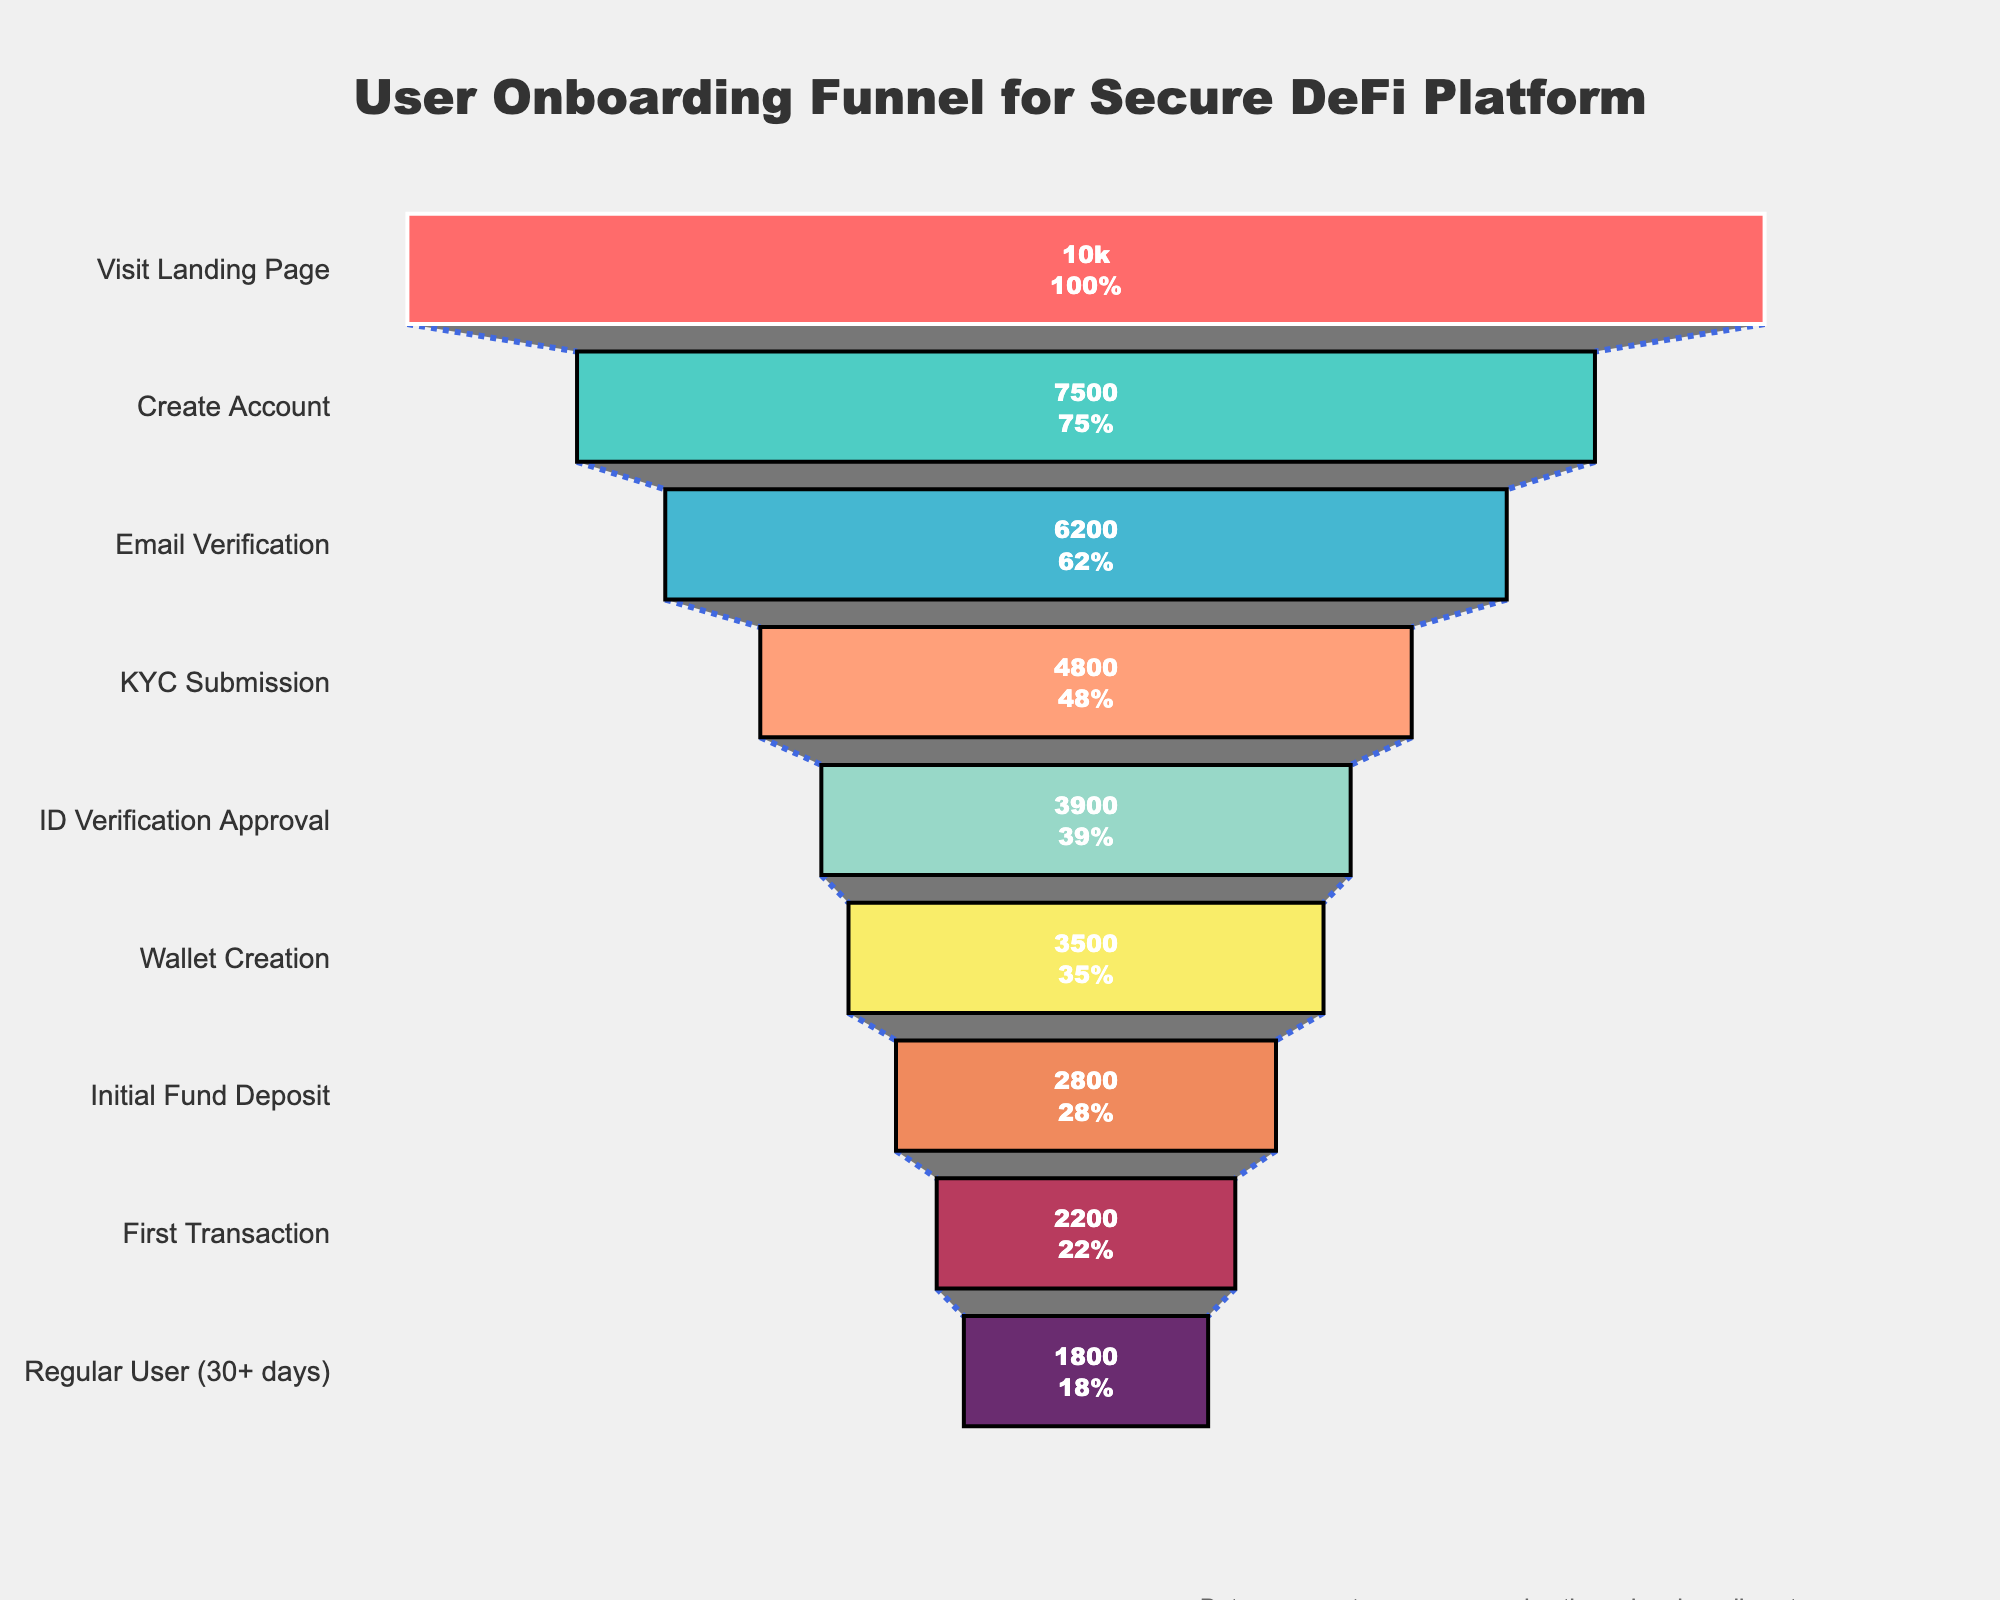What's the title of the funnel chart? The title of the funnel chart is displayed prominently at the top of the figure, which states the purpose or focus of the visualization.
Answer: User Onboarding Funnel for Secure DeFi Platform How many users completed the first transaction? The figure presents the number of users who reach each step of the onboarding process. Locate the step labeled "First Transaction" and refer to its associated user count.
Answer: 2200 What percentage of users completed the KYC Submission compared to the total visits to the landing page? The percentage for each step is calculated by dividing the number of users at that step by the number of users at the first step (Visit Landing Page) and then multiplying by 100. For KYC Submission: (4800/10000) * 100.
Answer: 48% What is the decrease in user count from Create Account to Email Verification? Subtract the number of users in the Email Verification step from the number of users in the Create Account step: 7500 - 6200.
Answer: 1300 Compare the number of users who completed ID Verification Approval and Wallet Creation. Which step had more users? Locate the steps "ID Verification Approval" and "Wallet Creation." Compare their user counts: 3900 (ID Verification Approval) vs 3500 (Wallet Creation).
Answer: ID Verification Approval What is the difference in completion rate between Initial Fund Deposit and Regular User (30+ days)? Compute the completion rate as the percentage of users for each respective step: Initial Fund Deposit (2800/10000) * 100 and Regular User (30+ days) (1800/10000) * 100, then find the difference (28% - 18%).
Answer: 10% How many steps are there in the user onboarding process? Count the number of distinct steps listed along the y-axis of the funnel chart, representing different stages of the user journey.
Answer: 9 At which step is there the highest drop-off rate? To determine the highest drop-off rate, identify where the difference between the user counts for consecutive steps is the largest. Analyze the differences between each step to find the maximum drop-off.
Answer: Create Account to Email Verification Which step in the funnel has the highest percentage of users from the original visit count? Identify the step with the most remaining users as a percentage of the initial visits, which translates to the highest bar in the funnel chart. The initial visit count is set at 10000 users, so all percentages are relative to this number.
Answer: Visit Landing Page 